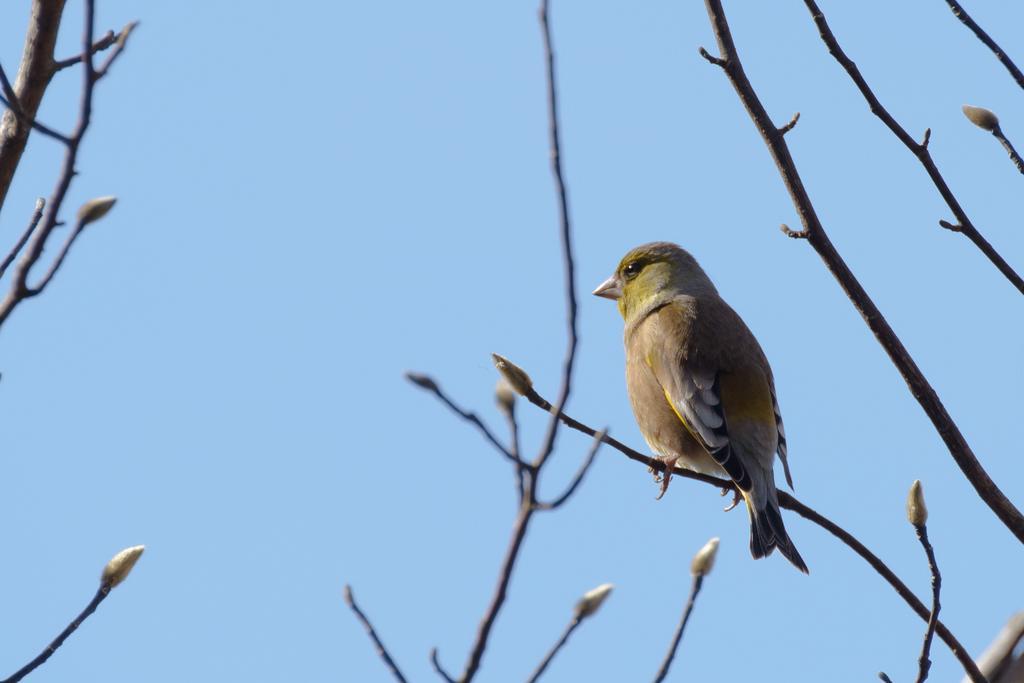Can you describe this image briefly? In this image we can see a bird on the stem. In the background there is sky. 